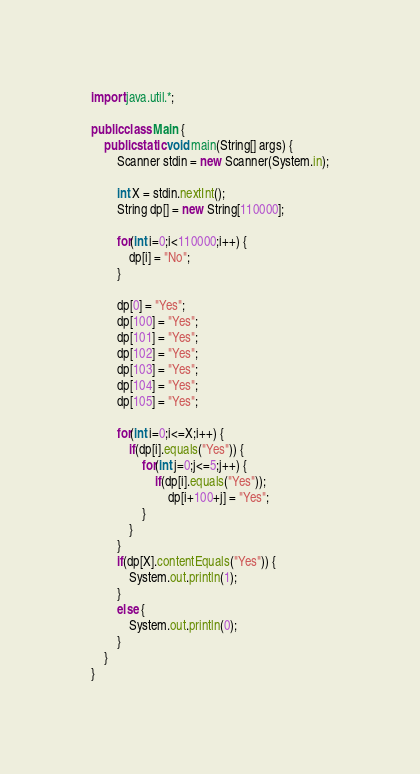<code> <loc_0><loc_0><loc_500><loc_500><_Java_>import java.util.*;

public class Main {
	public static void main(String[] args) {
		Scanner stdin = new Scanner(System.in);
		
		int X = stdin.nextInt();
		String dp[] = new String[110000];
		
		for(int i=0;i<110000;i++) {
			dp[i] = "No";
		}
		
		dp[0] = "Yes";
		dp[100] = "Yes";
		dp[101] = "Yes";
		dp[102] = "Yes";
		dp[103] = "Yes";
		dp[104] = "Yes";
		dp[105] = "Yes";
		
		for(int i=0;i<=X;i++) {
			if(dp[i].equals("Yes")) {
				for(int j=0;j<=5;j++) {
					if(dp[i].equals("Yes"));
						dp[i+100+j] = "Yes";
				}
			}
		}
		if(dp[X].contentEquals("Yes")) {
			System.out.println(1);
		}
		else {
			System.out.println(0);
		}
	}
}
</code> 